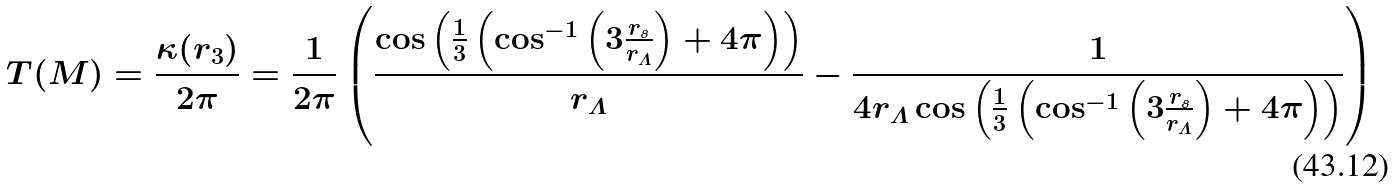<formula> <loc_0><loc_0><loc_500><loc_500>T ( M ) = \frac { \kappa ( r _ { 3 } ) } { 2 \pi } = \frac { 1 } { 2 \pi } \left ( \frac { \cos \left ( \frac { 1 } { 3 } \left ( \cos ^ { - 1 } \left ( 3 \frac { r _ { s } } { r _ { \varLambda } } \right ) + 4 \pi \right ) \right ) } { r _ { \varLambda } } - \frac { 1 } { 4 r _ { \varLambda } \cos \left ( \frac { 1 } { 3 } \left ( \cos ^ { - 1 } \left ( 3 \frac { r _ { s } } { r _ { \varLambda } } \right ) + 4 \pi \right ) \right ) } \right )</formula> 